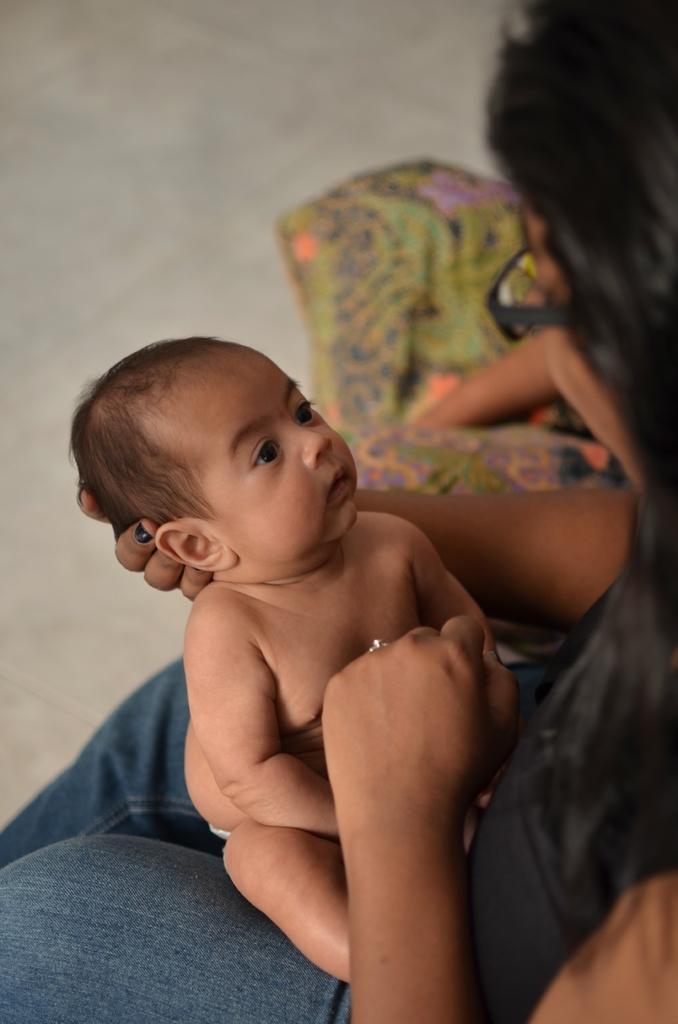Please provide a concise description of this image. In this picture there is a woman sitting and holding the baby and there is a person sitting. At the bottom there is a floor. 